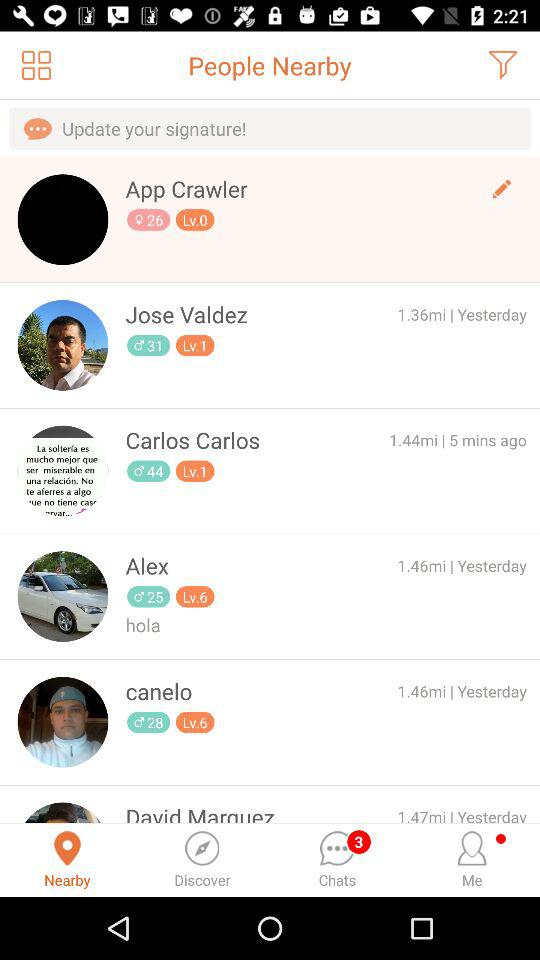What is the distance between you and Jose Valdez? The distance is 1.36 miles. 